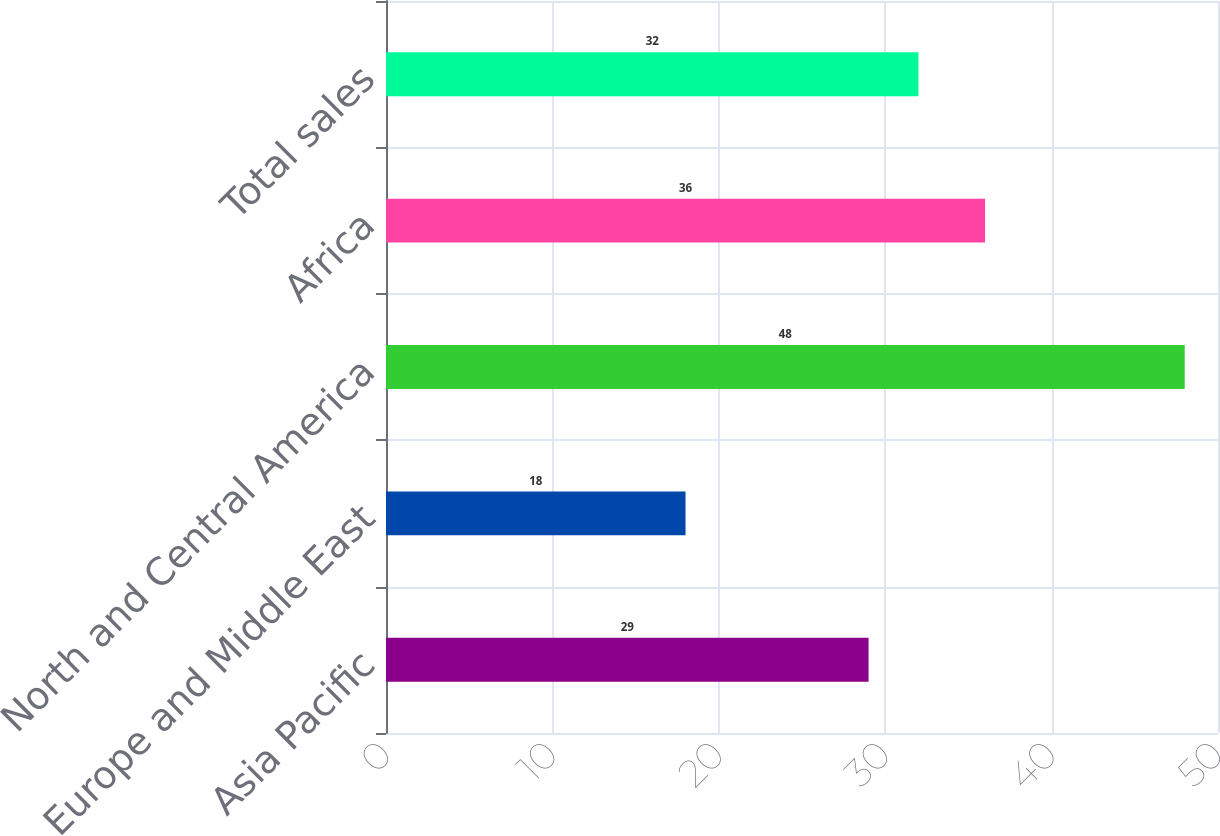<chart> <loc_0><loc_0><loc_500><loc_500><bar_chart><fcel>Asia Pacific<fcel>Europe and Middle East<fcel>North and Central America<fcel>Africa<fcel>Total sales<nl><fcel>29<fcel>18<fcel>48<fcel>36<fcel>32<nl></chart> 